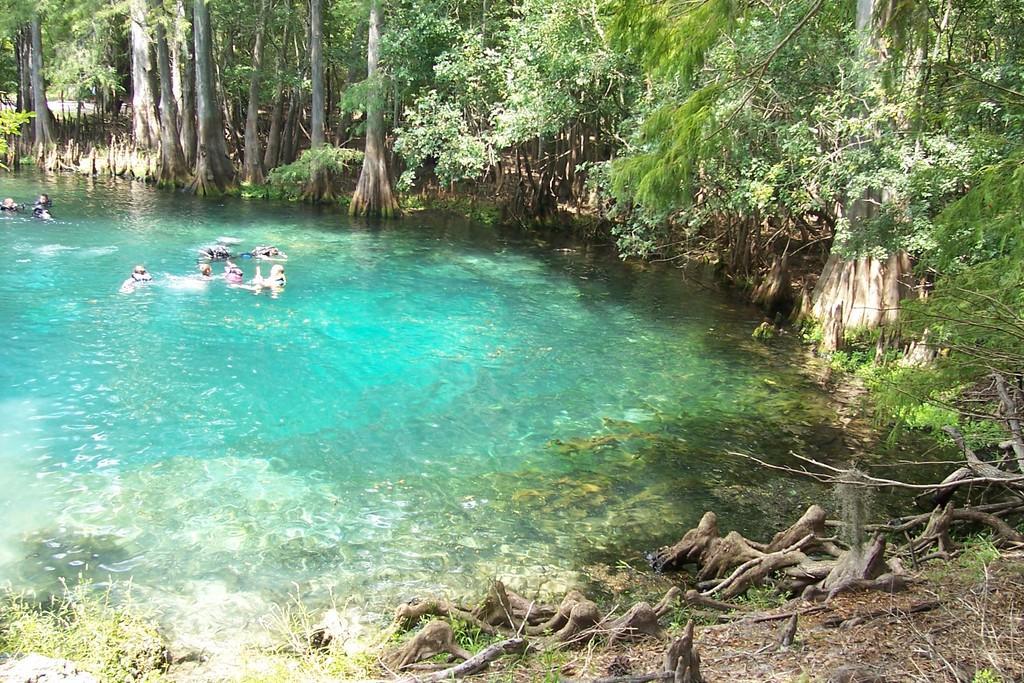Can you describe this image briefly? In the center of the image there is water, there are people swimming. In the background of the image there are trees. At the bottom of the image there are tree trunks and plants. 